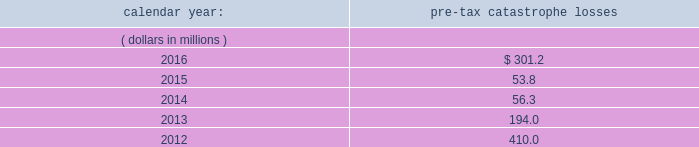Risks relating to our business fluctuations in the financial markets could result in investment losses .
Prolonged and severe disruptions in the overall public debt and equity markets , such as occurred during 2008 , could result in significant realized and unrealized losses in our investment portfolio .
Although financial markets have significantly improved since 2008 , they could deteriorate in the future .
There could also be disruption in individual market sectors , such as occurred in the energy sector in recent years .
Such declines in the financial markets could result in significant realized and unrealized losses on investments and could have a material adverse impact on our results of operations , equity , business and insurer financial strength and debt ratings .
Our results could be adversely affected by catastrophic events .
We are exposed to unpredictable catastrophic events , including weather-related and other natural catastrophes , as well as acts of terrorism .
Any material reduction in our operating results caused by the occurrence of one or more catastrophes could inhibit our ability to pay dividends or to meet our interest and principal payment obligations .
By way of illustration , during the past five calendar years , pre-tax catastrophe losses , net of contract specific reinsurance but before cessions under corporate reinsurance programs , were as follows: .
Our losses from future catastrophic events could exceed our projections .
We use projections of possible losses from future catastrophic events of varying types and magnitudes as a strategic underwriting tool .
We use these loss projections to estimate our potential catastrophe losses in certain geographic areas and decide on the placement of retrocessional coverage or other actions to limit the extent of potential losses in a given geographic area .
These loss projections are approximations , reliant on a mix of quantitative and qualitative processes , and actual losses may exceed the projections by a material amount , resulting in a material adverse effect on our financial condition and results of operations. .
What was the change in the amount of pre-tax catastrophe losses from 2015 to 2016 in millions? 
Computations: (301.2 - 53.8)
Answer: 247.4. 